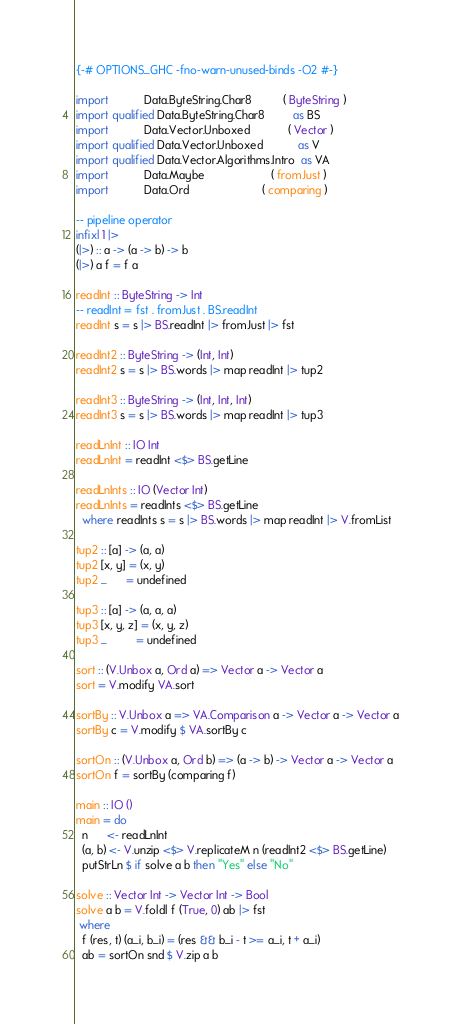Convert code to text. <code><loc_0><loc_0><loc_500><loc_500><_Haskell_>{-# OPTIONS_GHC -fno-warn-unused-binds -O2 #-}

import           Data.ByteString.Char8          ( ByteString )
import qualified Data.ByteString.Char8         as BS
import           Data.Vector.Unboxed            ( Vector )
import qualified Data.Vector.Unboxed           as V
import qualified Data.Vector.Algorithms.Intro  as VA
import           Data.Maybe                     ( fromJust )
import           Data.Ord                       ( comparing )

-- pipeline operator
infixl 1 |>
(|>) :: a -> (a -> b) -> b
(|>) a f = f a

readInt :: ByteString -> Int
-- readInt = fst . fromJust . BS.readInt
readInt s = s |> BS.readInt |> fromJust |> fst

readInt2 :: ByteString -> (Int, Int)
readInt2 s = s |> BS.words |> map readInt |> tup2

readInt3 :: ByteString -> (Int, Int, Int)
readInt3 s = s |> BS.words |> map readInt |> tup3

readLnInt :: IO Int
readLnInt = readInt <$> BS.getLine

readLnInts :: IO (Vector Int)
readLnInts = readInts <$> BS.getLine
  where readInts s = s |> BS.words |> map readInt |> V.fromList

tup2 :: [a] -> (a, a)
tup2 [x, y] = (x, y)
tup2 _      = undefined

tup3 :: [a] -> (a, a, a)
tup3 [x, y, z] = (x, y, z)
tup3 _         = undefined

sort :: (V.Unbox a, Ord a) => Vector a -> Vector a
sort = V.modify VA.sort

sortBy :: V.Unbox a => VA.Comparison a -> Vector a -> Vector a
sortBy c = V.modify $ VA.sortBy c

sortOn :: (V.Unbox a, Ord b) => (a -> b) -> Vector a -> Vector a
sortOn f = sortBy (comparing f)

main :: IO ()
main = do
  n      <- readLnInt
  (a, b) <- V.unzip <$> V.replicateM n (readInt2 <$> BS.getLine)
  putStrLn $ if solve a b then "Yes" else "No"

solve :: Vector Int -> Vector Int -> Bool
solve a b = V.foldl f (True, 0) ab |> fst
 where
  f (res, t) (a_i, b_i) = (res && b_i - t >= a_i, t + a_i)
  ab = sortOn snd $ V.zip a b
</code> 